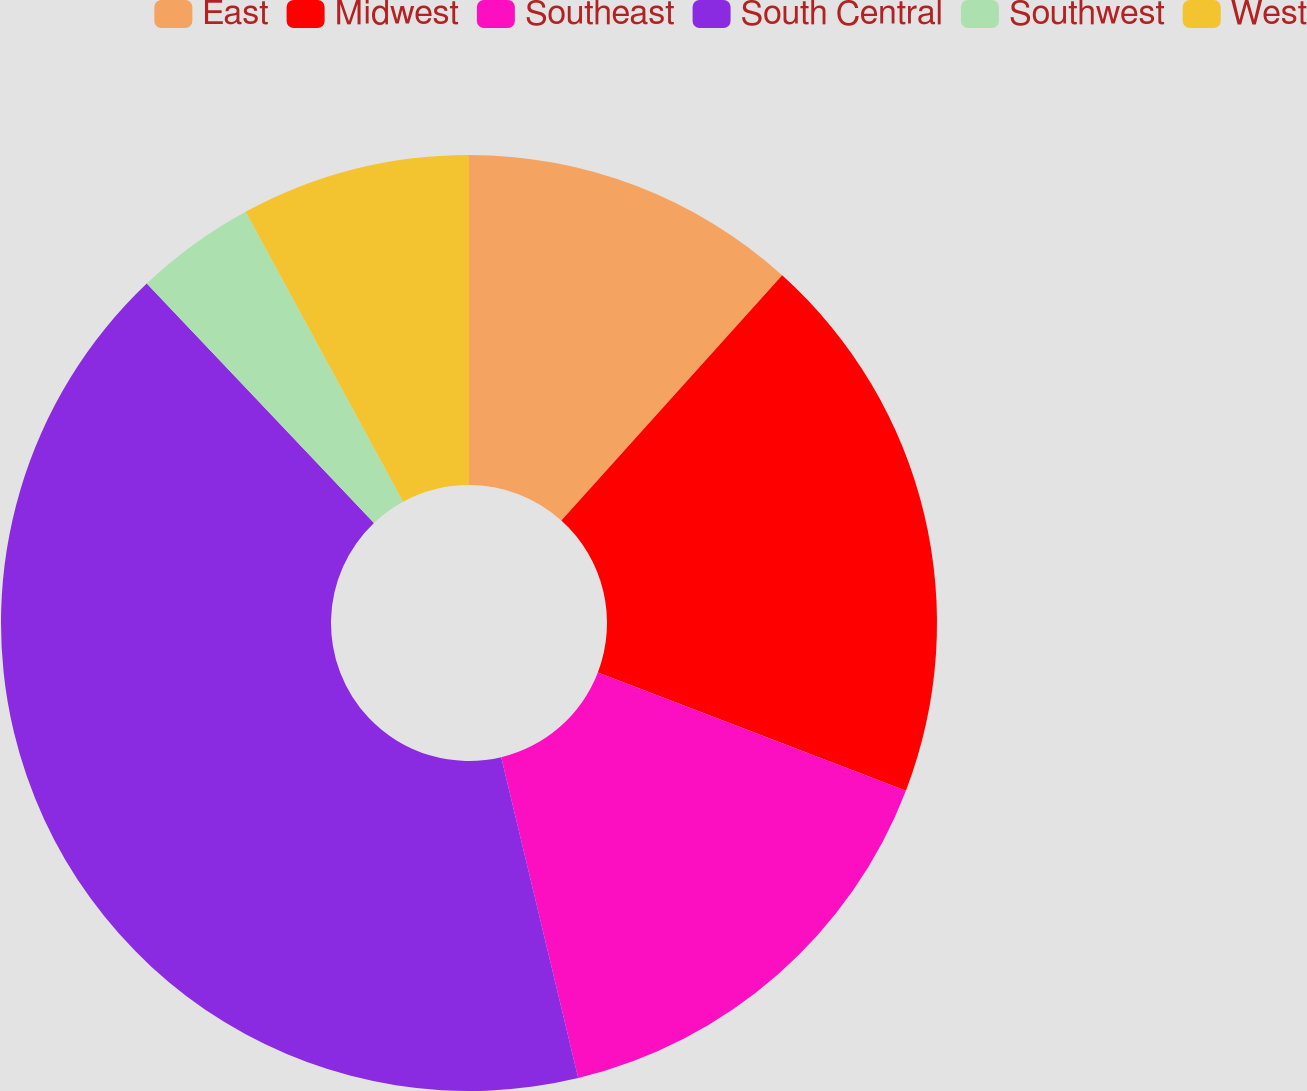<chart> <loc_0><loc_0><loc_500><loc_500><pie_chart><fcel>East<fcel>Midwest<fcel>Southeast<fcel>South Central<fcel>Southwest<fcel>West<nl><fcel>11.67%<fcel>19.17%<fcel>15.42%<fcel>41.67%<fcel>4.17%<fcel>7.92%<nl></chart> 